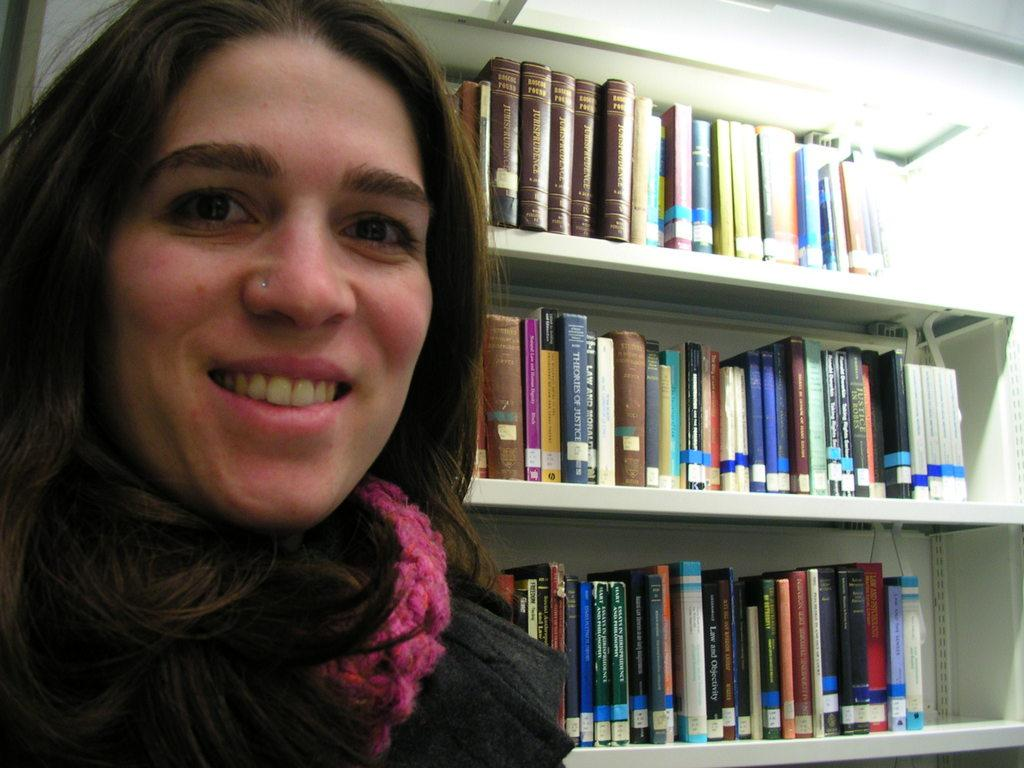Who is present in the image? There is a woman in the image. What is the woman's facial expression? The woman is smiling. What can be seen behind the woman? There is a bookshelf behind the woman. How many cattle are present in the image? There are no cattle present in the image. What type of committee is meeting in the image? There is no committee meeting in the image. 